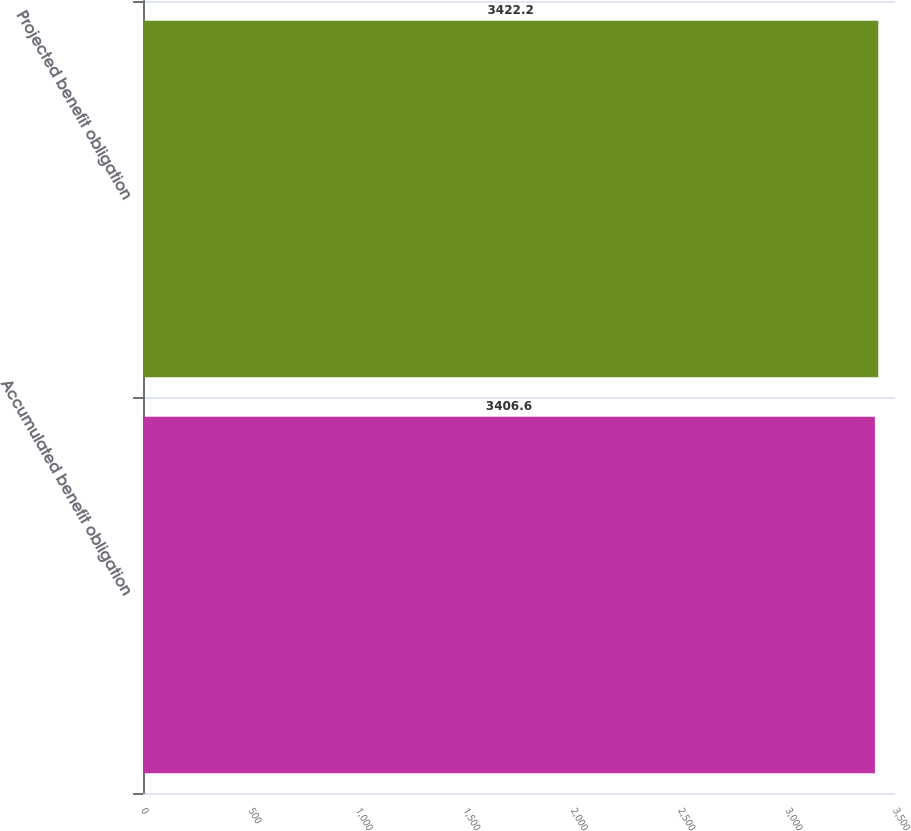<chart> <loc_0><loc_0><loc_500><loc_500><bar_chart><fcel>Accumulated benefit obligation<fcel>Projected benefit obligation<nl><fcel>3406.6<fcel>3422.2<nl></chart> 